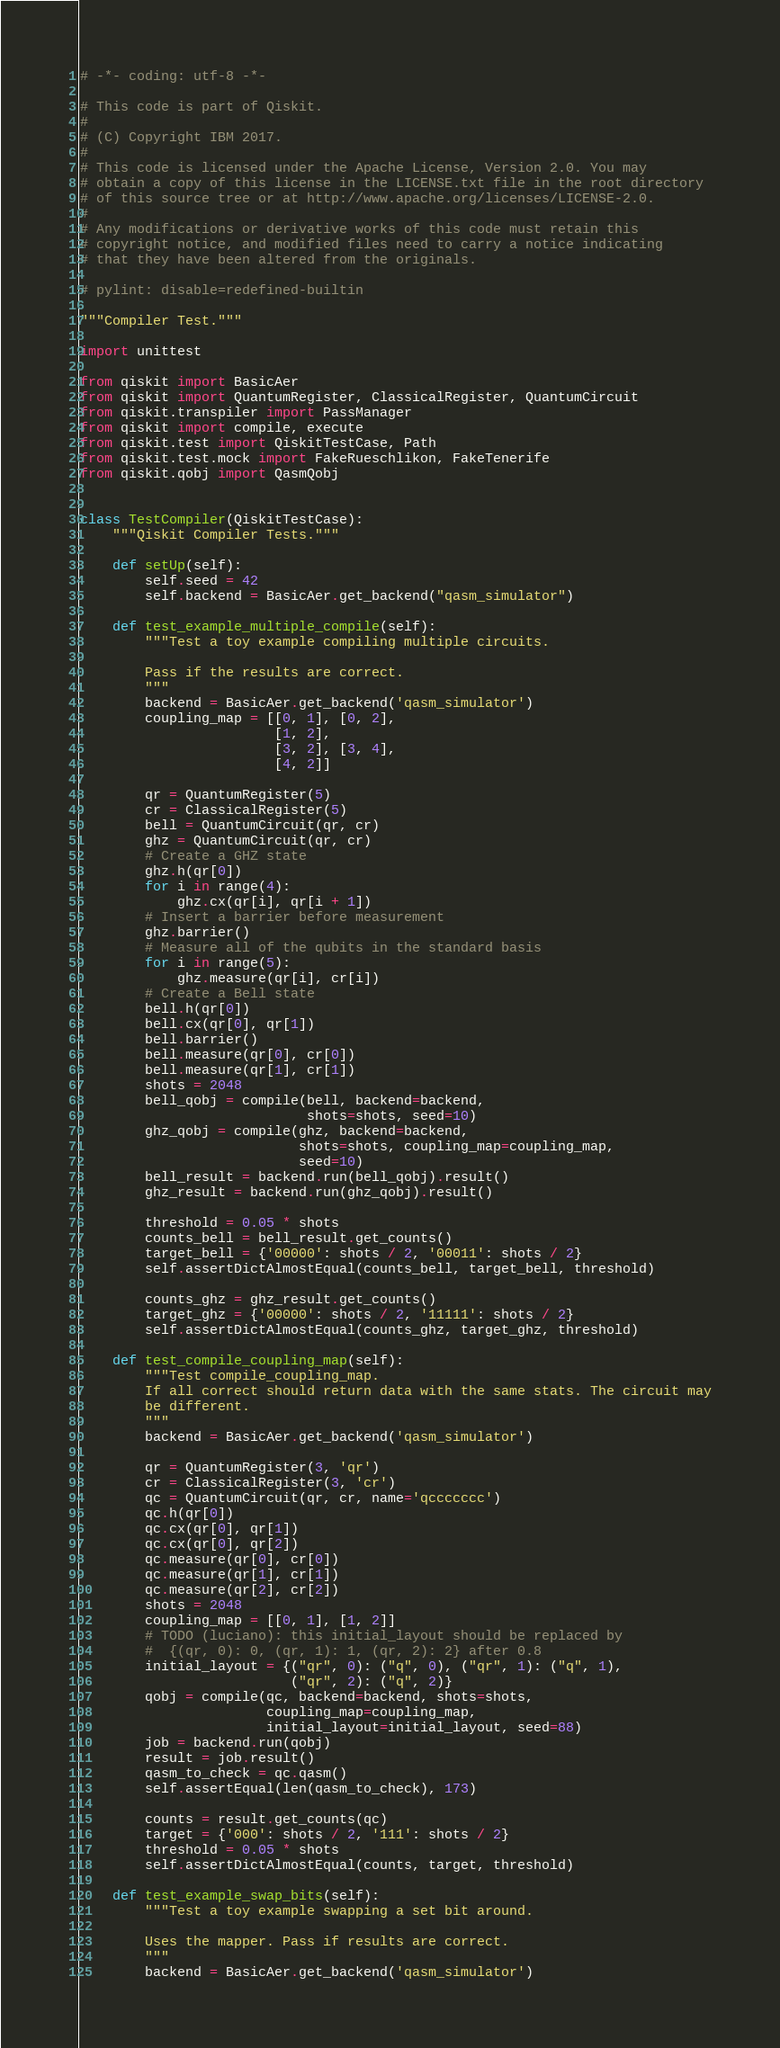Convert code to text. <code><loc_0><loc_0><loc_500><loc_500><_Python_># -*- coding: utf-8 -*-

# This code is part of Qiskit.
#
# (C) Copyright IBM 2017.
#
# This code is licensed under the Apache License, Version 2.0. You may
# obtain a copy of this license in the LICENSE.txt file in the root directory
# of this source tree or at http://www.apache.org/licenses/LICENSE-2.0.
#
# Any modifications or derivative works of this code must retain this
# copyright notice, and modified files need to carry a notice indicating
# that they have been altered from the originals.

# pylint: disable=redefined-builtin

"""Compiler Test."""

import unittest

from qiskit import BasicAer
from qiskit import QuantumRegister, ClassicalRegister, QuantumCircuit
from qiskit.transpiler import PassManager
from qiskit import compile, execute
from qiskit.test import QiskitTestCase, Path
from qiskit.test.mock import FakeRueschlikon, FakeTenerife
from qiskit.qobj import QasmQobj


class TestCompiler(QiskitTestCase):
    """Qiskit Compiler Tests."""

    def setUp(self):
        self.seed = 42
        self.backend = BasicAer.get_backend("qasm_simulator")

    def test_example_multiple_compile(self):
        """Test a toy example compiling multiple circuits.

        Pass if the results are correct.
        """
        backend = BasicAer.get_backend('qasm_simulator')
        coupling_map = [[0, 1], [0, 2],
                        [1, 2],
                        [3, 2], [3, 4],
                        [4, 2]]

        qr = QuantumRegister(5)
        cr = ClassicalRegister(5)
        bell = QuantumCircuit(qr, cr)
        ghz = QuantumCircuit(qr, cr)
        # Create a GHZ state
        ghz.h(qr[0])
        for i in range(4):
            ghz.cx(qr[i], qr[i + 1])
        # Insert a barrier before measurement
        ghz.barrier()
        # Measure all of the qubits in the standard basis
        for i in range(5):
            ghz.measure(qr[i], cr[i])
        # Create a Bell state
        bell.h(qr[0])
        bell.cx(qr[0], qr[1])
        bell.barrier()
        bell.measure(qr[0], cr[0])
        bell.measure(qr[1], cr[1])
        shots = 2048
        bell_qobj = compile(bell, backend=backend,
                            shots=shots, seed=10)
        ghz_qobj = compile(ghz, backend=backend,
                           shots=shots, coupling_map=coupling_map,
                           seed=10)
        bell_result = backend.run(bell_qobj).result()
        ghz_result = backend.run(ghz_qobj).result()

        threshold = 0.05 * shots
        counts_bell = bell_result.get_counts()
        target_bell = {'00000': shots / 2, '00011': shots / 2}
        self.assertDictAlmostEqual(counts_bell, target_bell, threshold)

        counts_ghz = ghz_result.get_counts()
        target_ghz = {'00000': shots / 2, '11111': shots / 2}
        self.assertDictAlmostEqual(counts_ghz, target_ghz, threshold)

    def test_compile_coupling_map(self):
        """Test compile_coupling_map.
        If all correct should return data with the same stats. The circuit may
        be different.
        """
        backend = BasicAer.get_backend('qasm_simulator')

        qr = QuantumRegister(3, 'qr')
        cr = ClassicalRegister(3, 'cr')
        qc = QuantumCircuit(qr, cr, name='qccccccc')
        qc.h(qr[0])
        qc.cx(qr[0], qr[1])
        qc.cx(qr[0], qr[2])
        qc.measure(qr[0], cr[0])
        qc.measure(qr[1], cr[1])
        qc.measure(qr[2], cr[2])
        shots = 2048
        coupling_map = [[0, 1], [1, 2]]
        # TODO (luciano): this initial_layout should be replaced by
        #  {(qr, 0): 0, (qr, 1): 1, (qr, 2): 2} after 0.8
        initial_layout = {("qr", 0): ("q", 0), ("qr", 1): ("q", 1),
                          ("qr", 2): ("q", 2)}
        qobj = compile(qc, backend=backend, shots=shots,
                       coupling_map=coupling_map,
                       initial_layout=initial_layout, seed=88)
        job = backend.run(qobj)
        result = job.result()
        qasm_to_check = qc.qasm()
        self.assertEqual(len(qasm_to_check), 173)

        counts = result.get_counts(qc)
        target = {'000': shots / 2, '111': shots / 2}
        threshold = 0.05 * shots
        self.assertDictAlmostEqual(counts, target, threshold)

    def test_example_swap_bits(self):
        """Test a toy example swapping a set bit around.

        Uses the mapper. Pass if results are correct.
        """
        backend = BasicAer.get_backend('qasm_simulator')</code> 